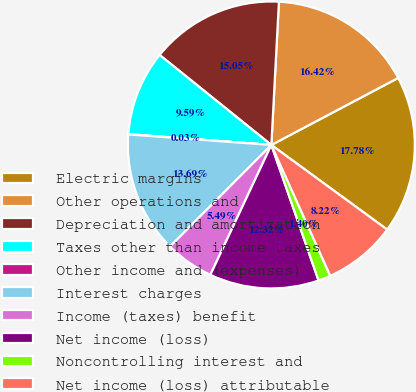Convert chart to OTSL. <chart><loc_0><loc_0><loc_500><loc_500><pie_chart><fcel>Electric margins<fcel>Other operations and<fcel>Depreciation and amortization<fcel>Taxes other than income taxes<fcel>Other income and (expenses)<fcel>Interest charges<fcel>Income (taxes) benefit<fcel>Net income (loss)<fcel>Noncontrolling interest and<fcel>Net income (loss) attributable<nl><fcel>17.78%<fcel>16.42%<fcel>15.05%<fcel>9.59%<fcel>0.03%<fcel>13.69%<fcel>5.49%<fcel>12.32%<fcel>1.4%<fcel>8.22%<nl></chart> 